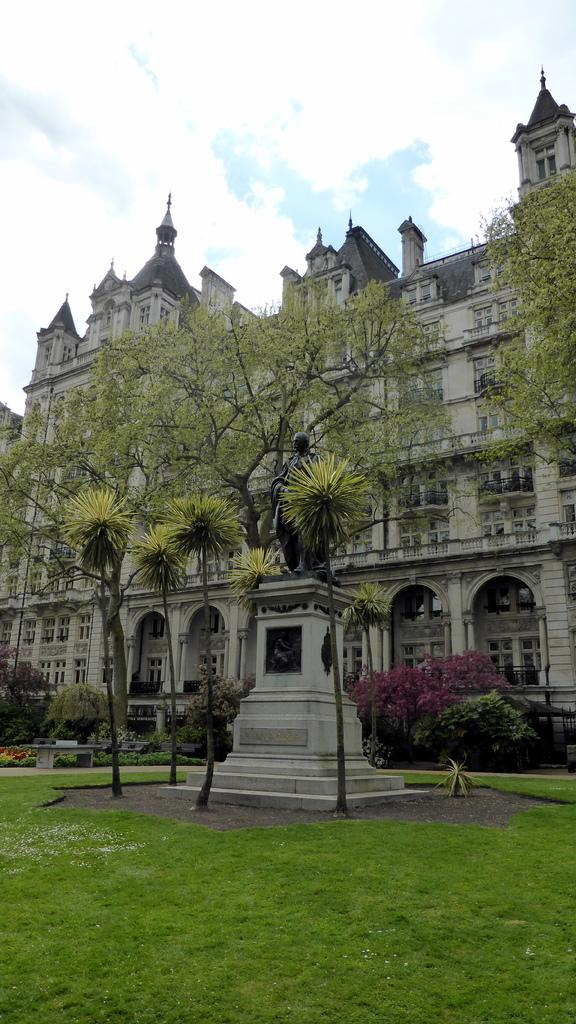What type of vegetation is present on the ground in the front of the image? There is grass on the ground in the front of the image. What can be seen in the background of the image? There are trees and a castle in the background of the image. What is the condition of the sky in the image? The sky is cloudy in the image. What color is the shirt worn by the castle in the image? There is no shirt present in the image, as the castle is a building and not a person. 